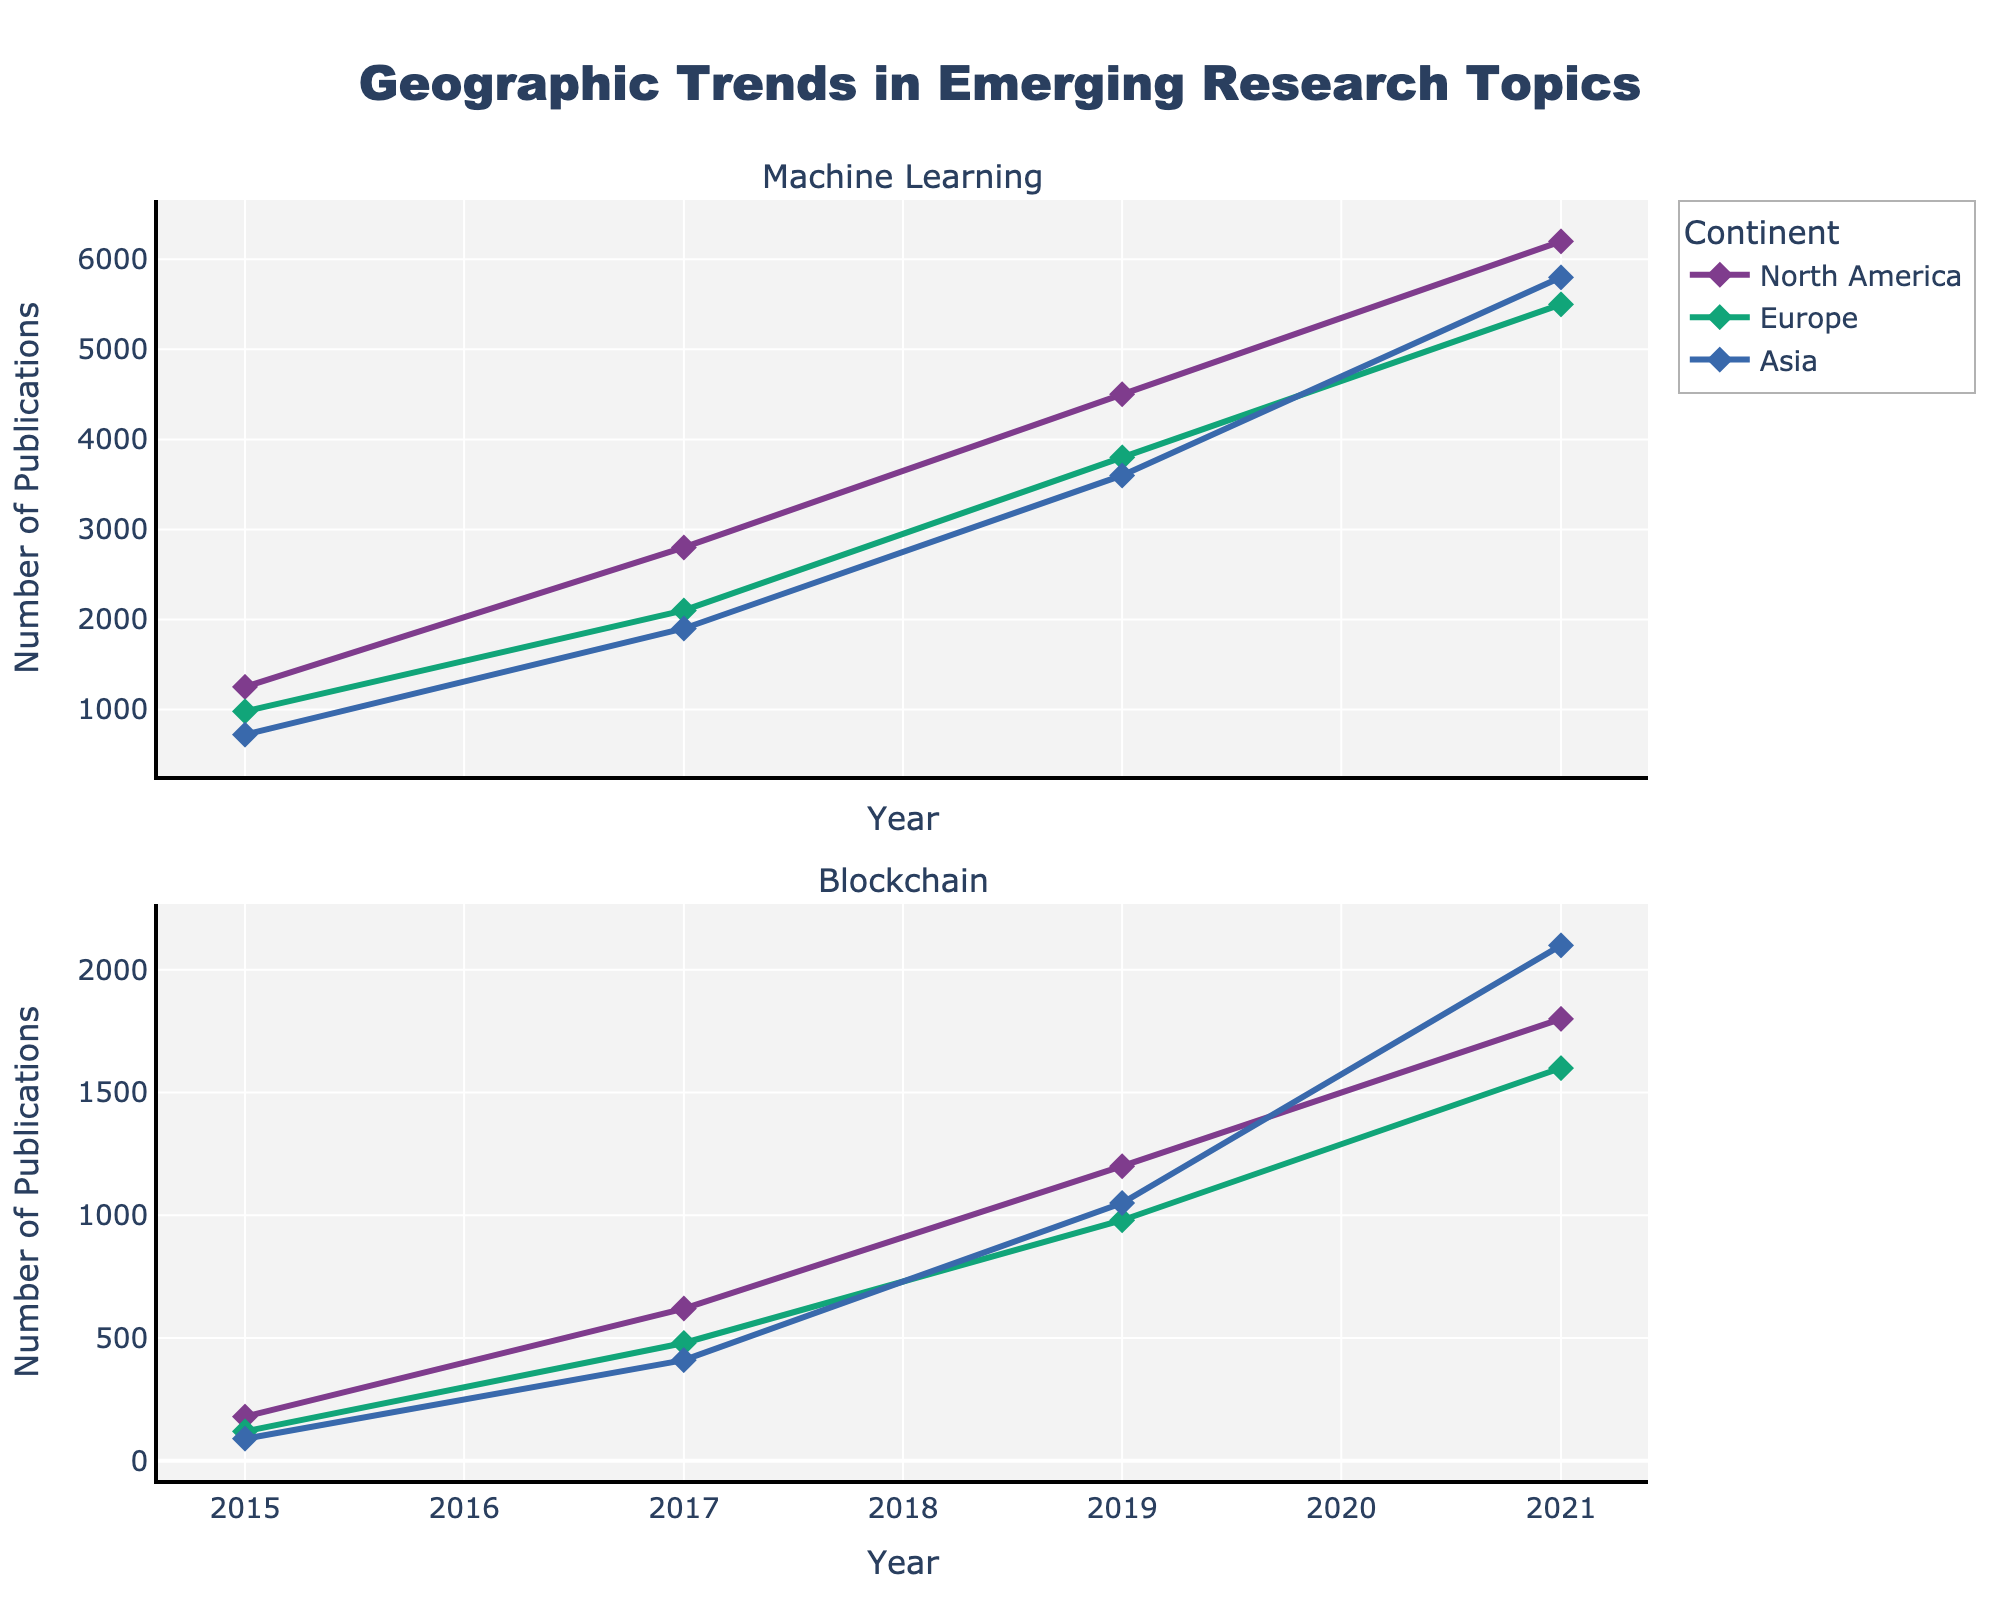What is the title of the plot? The title can be found at the top of the figure, indicating the main focus.
Answer: Geographic Trends in Emerging Research Topics Which continent had the highest number of publications in Machine Learning in 2021? By checking the 2021 data in the Machine Learning subplot, the highest trend line can be identified.
Answer: Asia How did the number of Machine Learning publications change in North America from 2015 to 2021? We need to compare the data points for 2015 and 2021 in the North America series within the Machine Learning subplot.
Answer: Increased from 1250 to 6200 In 2017, which continent had the least number of publications in Blockchain? Look at the 2017 data points in the Blockchain subplot and identify the smallest value among all continents.
Answer: Asia What trend can you observe in the Blockchain publications in Asia from 2015 to 2021? Visually track the trend line for Asia in the Blockchain subplot from 2015 to 2021, noting the overall direction of change.
Answer: Increasing Between the two topics, which one had more uniform growth across continents from 2015 to 2021? Analyzing the trend lines for both topics across continents, identify which topic shows more consistent growth patterns.
Answer: Machine Learning 